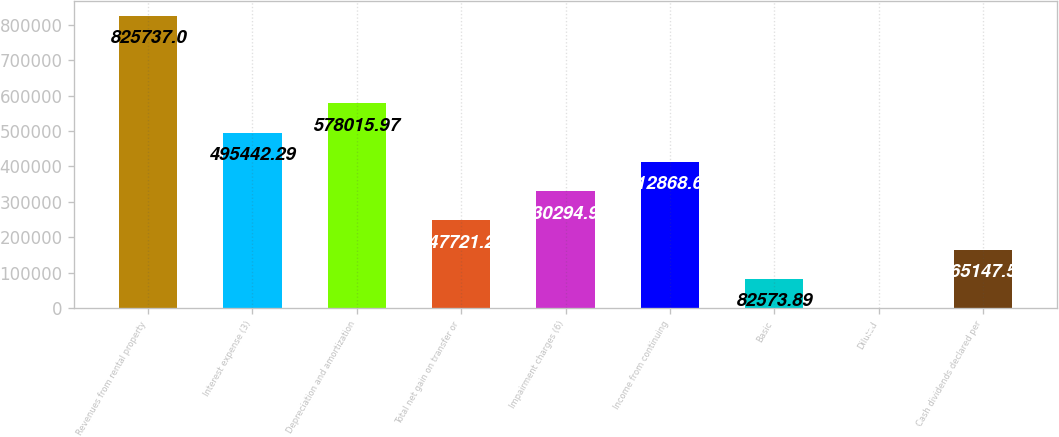<chart> <loc_0><loc_0><loc_500><loc_500><bar_chart><fcel>Revenues from rental property<fcel>Interest expense (3)<fcel>Depreciation and amortization<fcel>Total net gain on transfer or<fcel>Impairment charges (6)<fcel>Income from continuing<fcel>Basic<fcel>Diluted<fcel>Cash dividends declared per<nl><fcel>825737<fcel>495442<fcel>578016<fcel>247721<fcel>330295<fcel>412869<fcel>82573.9<fcel>0.21<fcel>165148<nl></chart> 